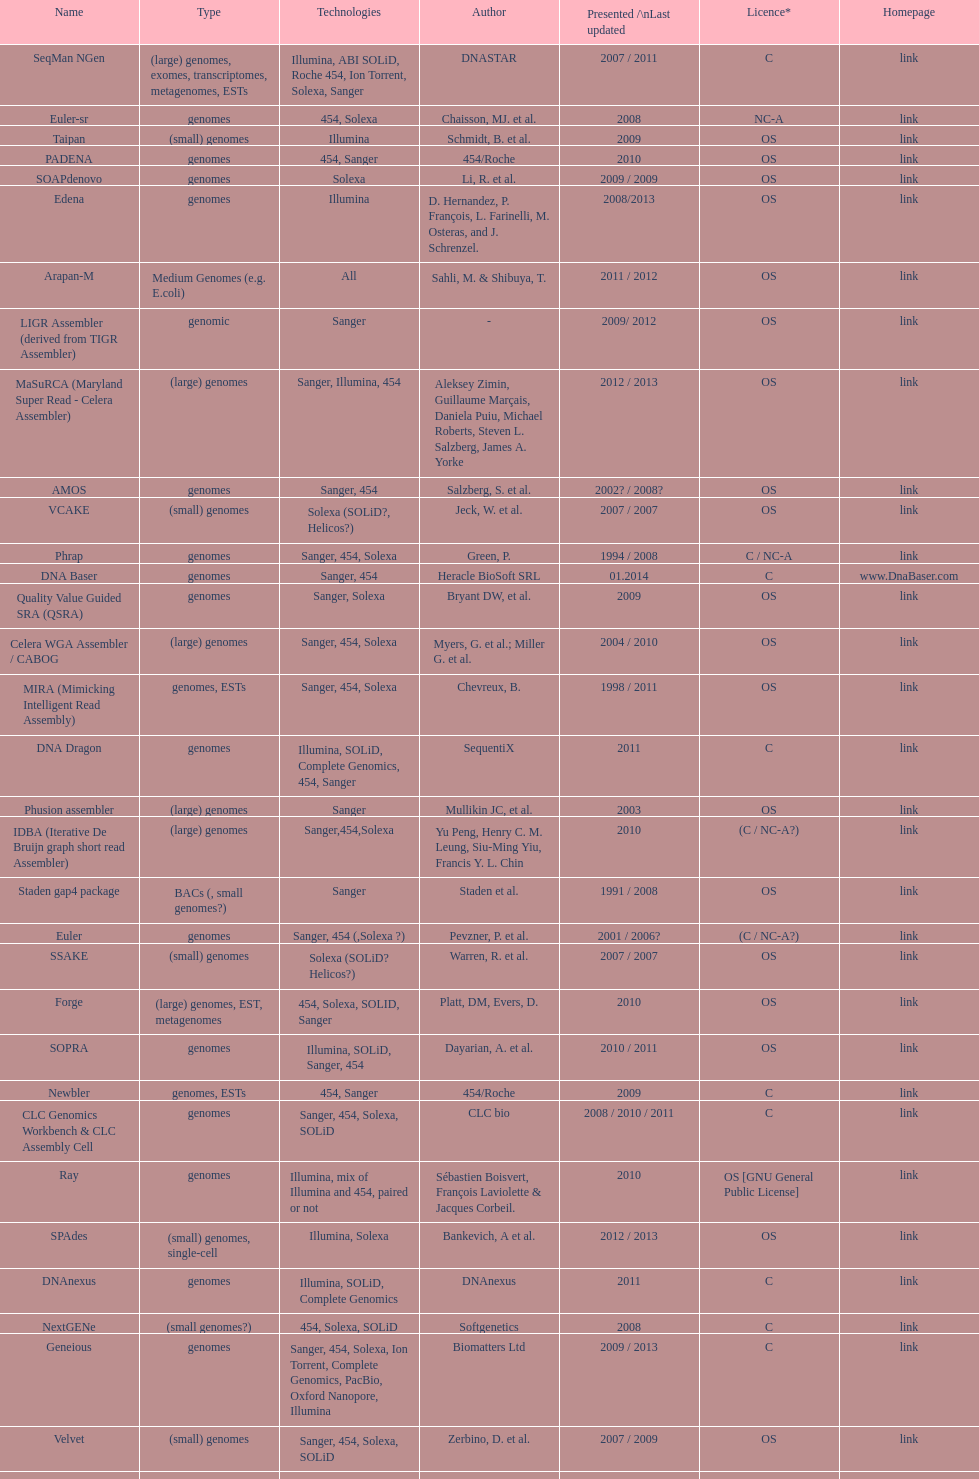Which license is listed more, os or c? OS. 